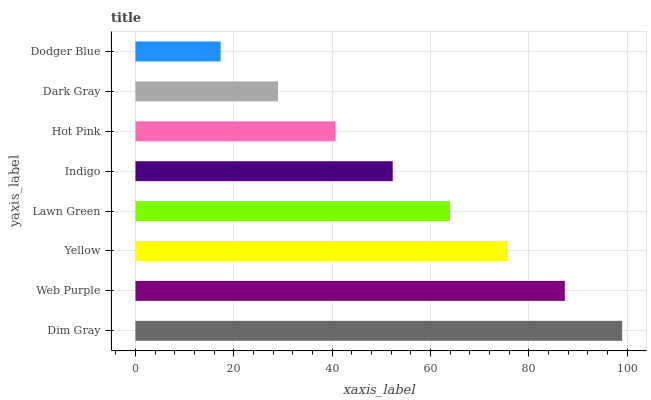Is Dodger Blue the minimum?
Answer yes or no. Yes. Is Dim Gray the maximum?
Answer yes or no. Yes. Is Web Purple the minimum?
Answer yes or no. No. Is Web Purple the maximum?
Answer yes or no. No. Is Dim Gray greater than Web Purple?
Answer yes or no. Yes. Is Web Purple less than Dim Gray?
Answer yes or no. Yes. Is Web Purple greater than Dim Gray?
Answer yes or no. No. Is Dim Gray less than Web Purple?
Answer yes or no. No. Is Lawn Green the high median?
Answer yes or no. Yes. Is Indigo the low median?
Answer yes or no. Yes. Is Dim Gray the high median?
Answer yes or no. No. Is Dim Gray the low median?
Answer yes or no. No. 